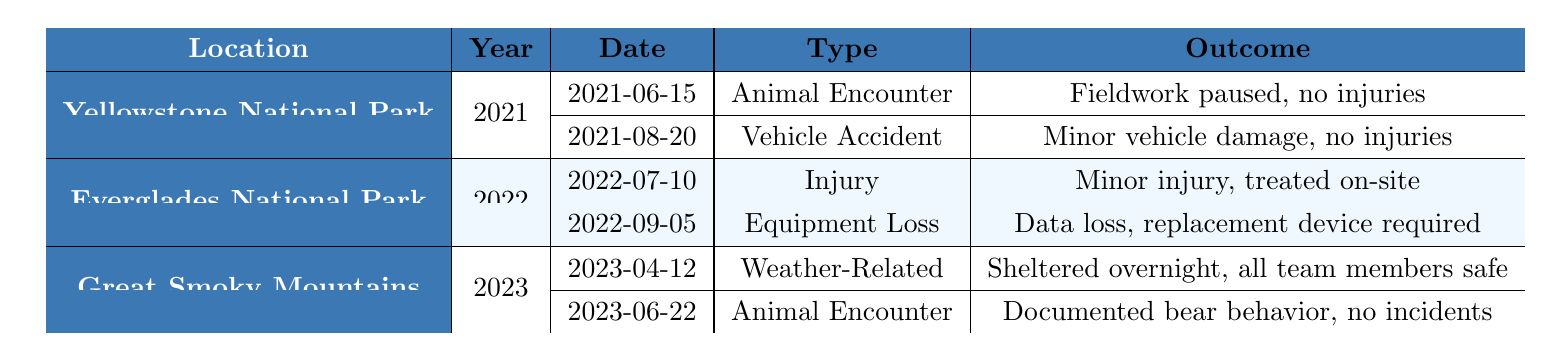What incidents occurred in Yellowstone National Park in 2021? The table shows two incidents in Yellowstone National Park for the year 2021: an animal encounter on June 15 and a vehicle accident on August 20.
Answer: Animal encounter and vehicle accident How many incidents were reported in Everglades National Park in 2022? There are two incidents reported in Everglades National Park for the year 2022, based on the entries in the table.
Answer: 2 What type of incident occurred on July 10, 2022, in Everglades National Park? The incident on July 10, 2022, is categorized as an injury, as listed in the table for that date.
Answer: Injury Was there a weather-related incident reported in Great Smoky Mountains? Yes, there was a weather-related incident reported on April 12, 2023, according to the table.
Answer: Yes What is the outcome of the vehicle accident in Yellowstone National Park? The outcome for the vehicle accident incident on August 20, 2021, is minor vehicle damage with no injuries reported.
Answer: Minor vehicle damage, no injuries How many total different types of incidents are documented across all three locations? There are five different types of incidents: Animal Encounter, Vehicle Accident, Injury, Equipment Loss, and Weather-Related.
Answer: 5 Which park had incidents related to animal encounters, and how many were there? Both Yellowstone National Park and Great Smoky Mountains had incidents related to animal encounters, with one incident in each location.
Answer: 2 What was the primary outcome for the incident involving a bite from an alligator? The outcome for the incident involving a bite from an alligator on July 10, 2022, was a minor injury treated on-site as stated in the table.
Answer: Minor injury, treated on-site How many incident reports in total occurred in 2021 compared to 2022? There were a total of 2 incident reports in 2021 and 2 incident reports in 2022, based on the data presented in the table.
Answer: Equal (2 each) What was the most recent incident reported in the table and what was its outcome? The most recent incident reported in the table occurred on June 22, 2023, which was an animal encounter that resulted in documented bear behavior with no incidents.
Answer: Documented bear behavior, no incidents 